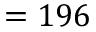<formula> <loc_0><loc_0><loc_500><loc_500>= 1 9 6</formula> 